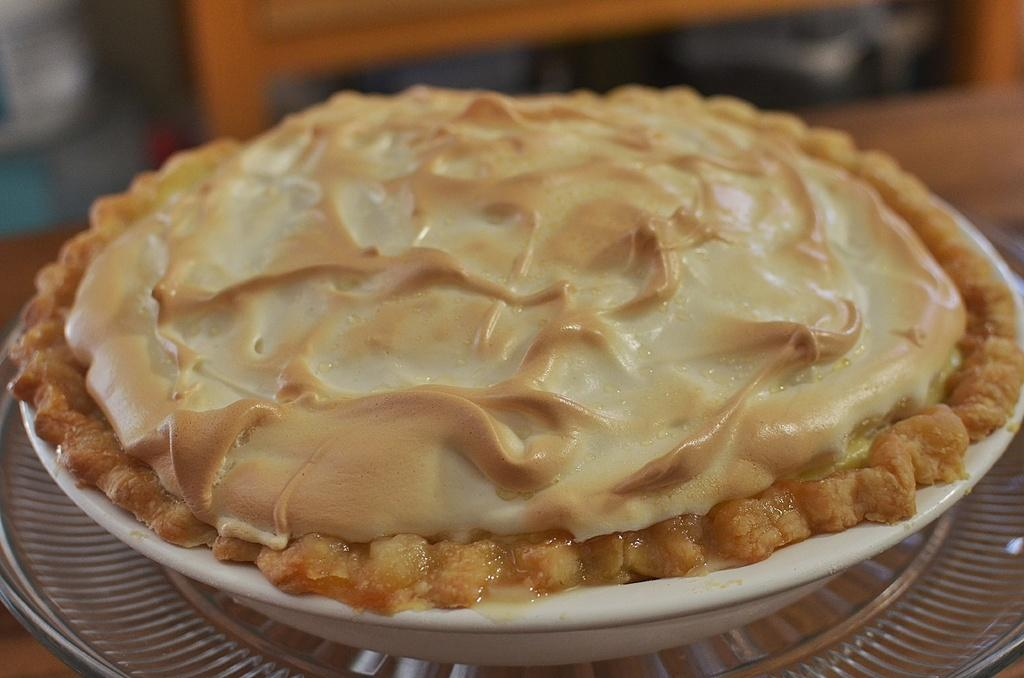What is in the bowl that is visible in the image? The bowl contains a cake. What is on top of the cake in the image? The cake has cream on it. What can be seen in the background of the image? There is a wooden plank in the background of the image. How many snails are crawling on the cake in the image? There are no snails present on the cake in the image. What level of difficulty is the cake for a beginner baker? The image does not provide information about the difficulty level of the cake for a beginner baker. 